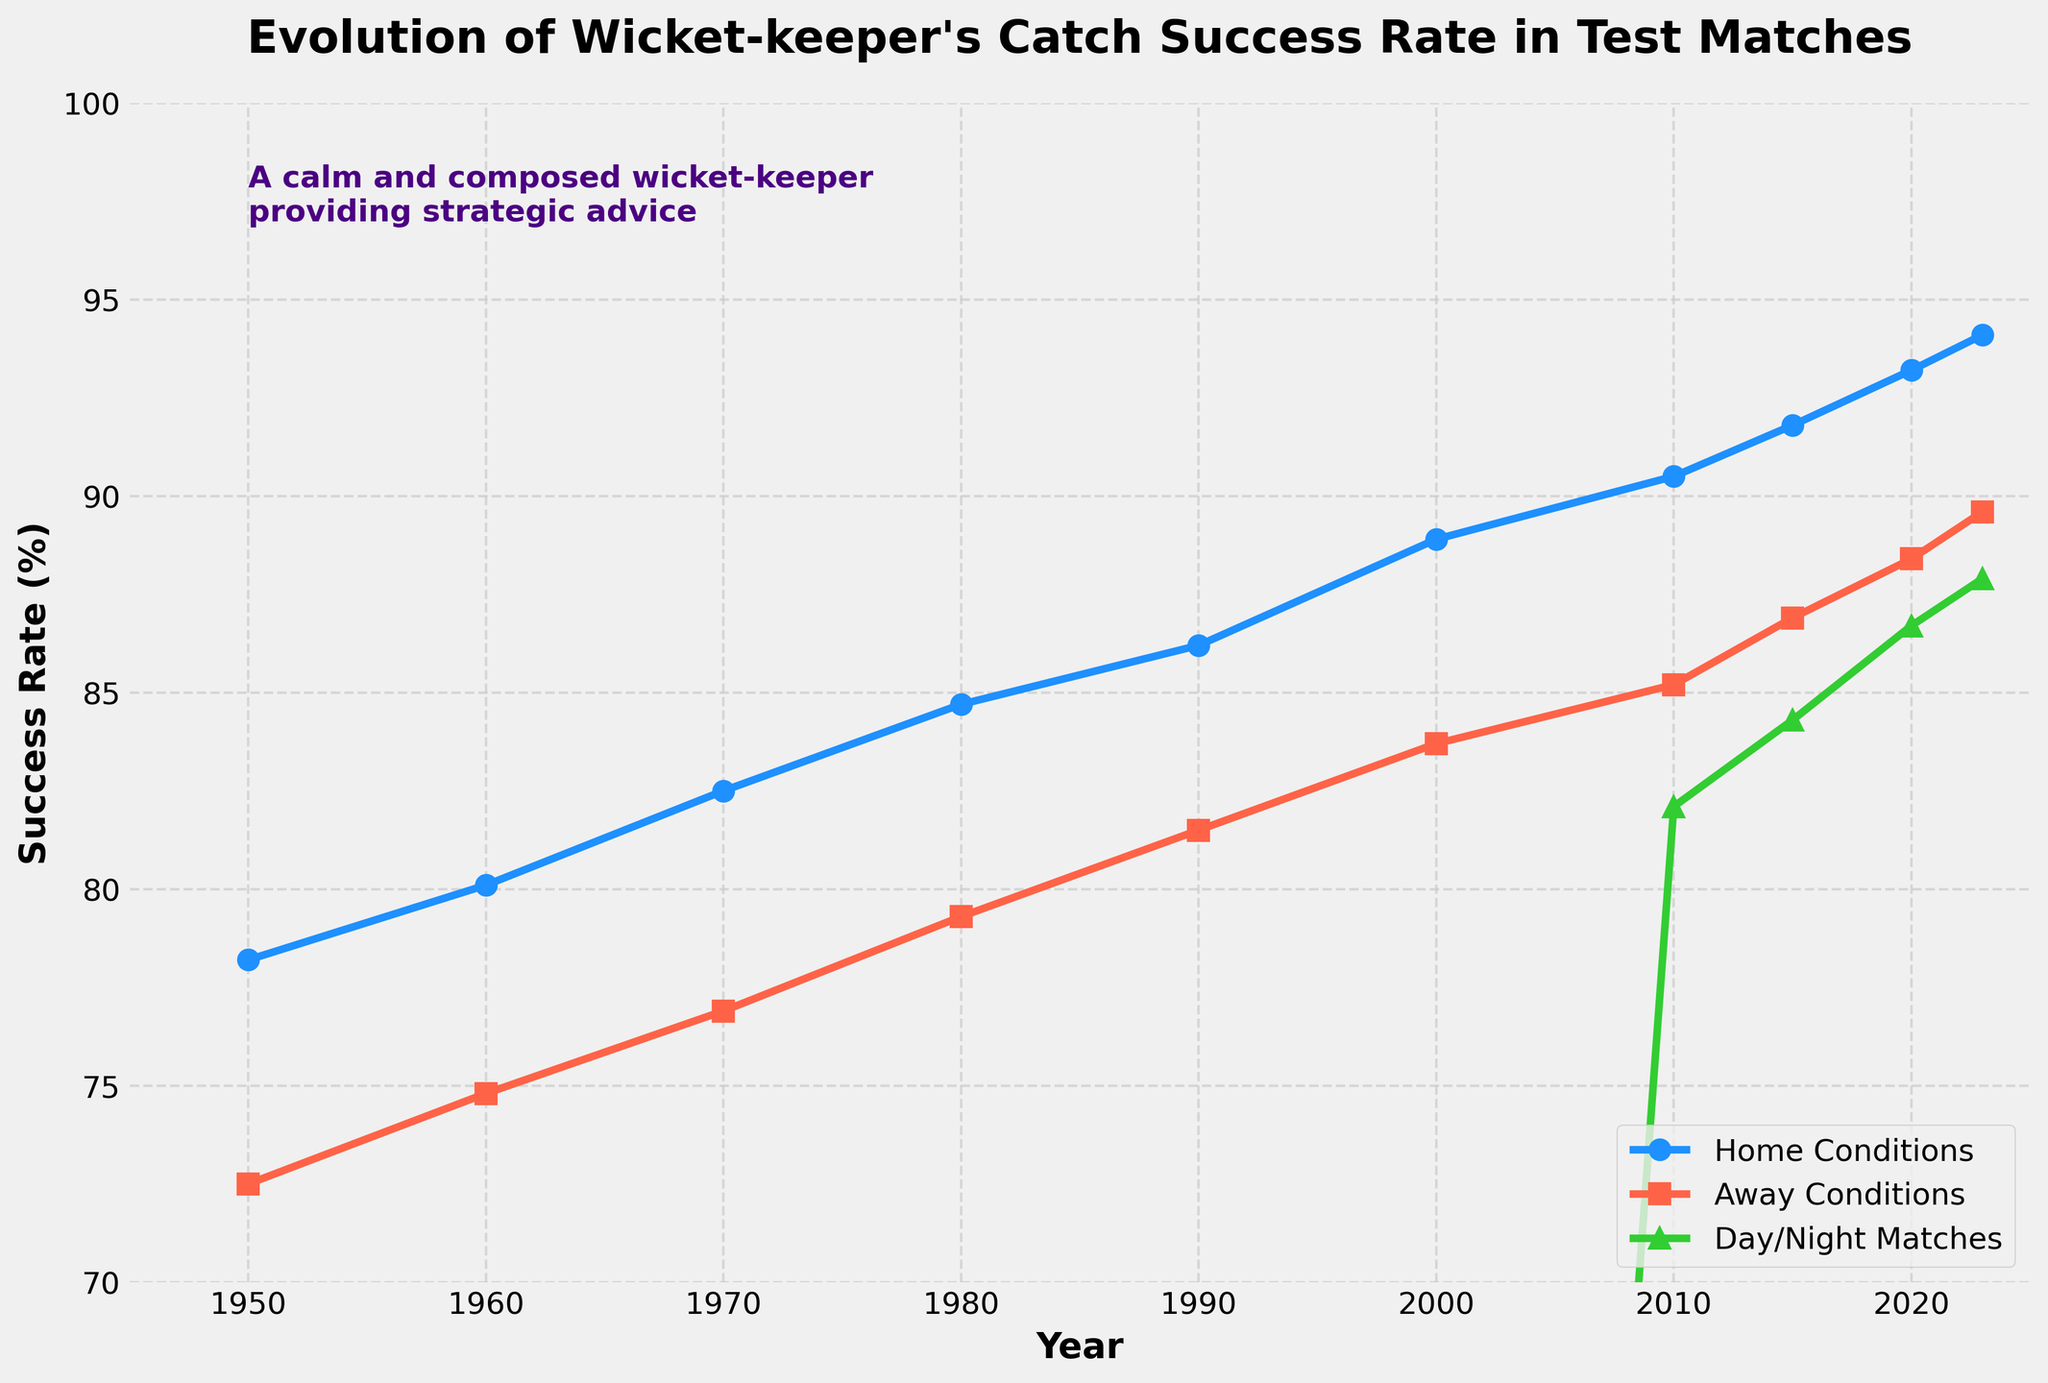What's the difference in the catch success rate at home between 1950 and 2023? To find the difference, look at the catch success rate for home conditions in 1950 (78.2%) and in 2023 (94.1%). Subtract the 1950 value from the 2023 value: 94.1% - 78.2% = 15.9%
Answer: 15.9% Which playing condition had the highest success rate in 2023? In 2023, compare the values for home conditions (94.1%), away conditions (89.6%), and day/night matches (87.9%). The highest value is for home conditions.
Answer: Home Conditions How did the success rate for away conditions change from 2000 to 2020? Look at the away conditions success rates for 2000 (83.7%) and 2020 (88.4%). The difference is 88.4% - 83.7% = 4.7%.
Answer: Increased by 4.7% In which year did day/night matches have a success rate higher than away conditions for the first time? Evaluate the years starting from 2010, when data for day/night matches first appears. In 2020, the day/night matches success rate (86.7%) exceeds the away conditions success rate (88.4%). Therefore, the first occurrence is in 2020.
Answer: 2020 Between 2010 and 2023, which playing condition showed the most improvement? To determine the improvement, calculate the difference for each condition: Home conditions (94.1% - 90.5% = 3.6%), Away conditions (89.6% - 85.2% = 4.4%), Day/night matches (87.9% - 82.1% = 5.8%). The greatest increase is in day/night matches.
Answer: Day/Night Matches What is the average success rate for away conditions from 1950 to 2023? Calculate the mean of the away conditions: (72.5 + 74.8 + 76.9 + 79.3 + 81.5 + 83.7 + 85.2 + 86.9 + 88.4 + 89.6) / 10 = 81.88%
Answer: 81.88% How many years did the success rate exceed 85% for home conditions in the dataset? Identify the years where the home conditions success rate is greater than 85%: 2000 (88.9%), 2010 (90.5%), 2015 (91.8%), 2020 (93.2%), and 2023 (94.1%). This occurs in 5 years.
Answer: 5 Years 